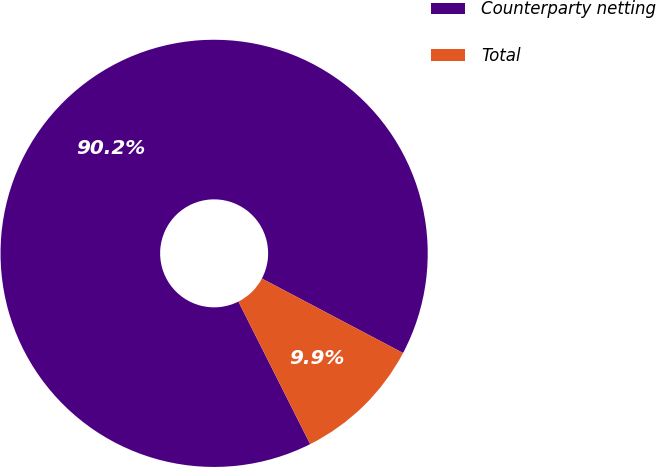Convert chart. <chart><loc_0><loc_0><loc_500><loc_500><pie_chart><fcel>Counterparty netting<fcel>Total<nl><fcel>90.15%<fcel>9.85%<nl></chart> 